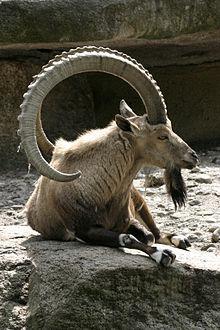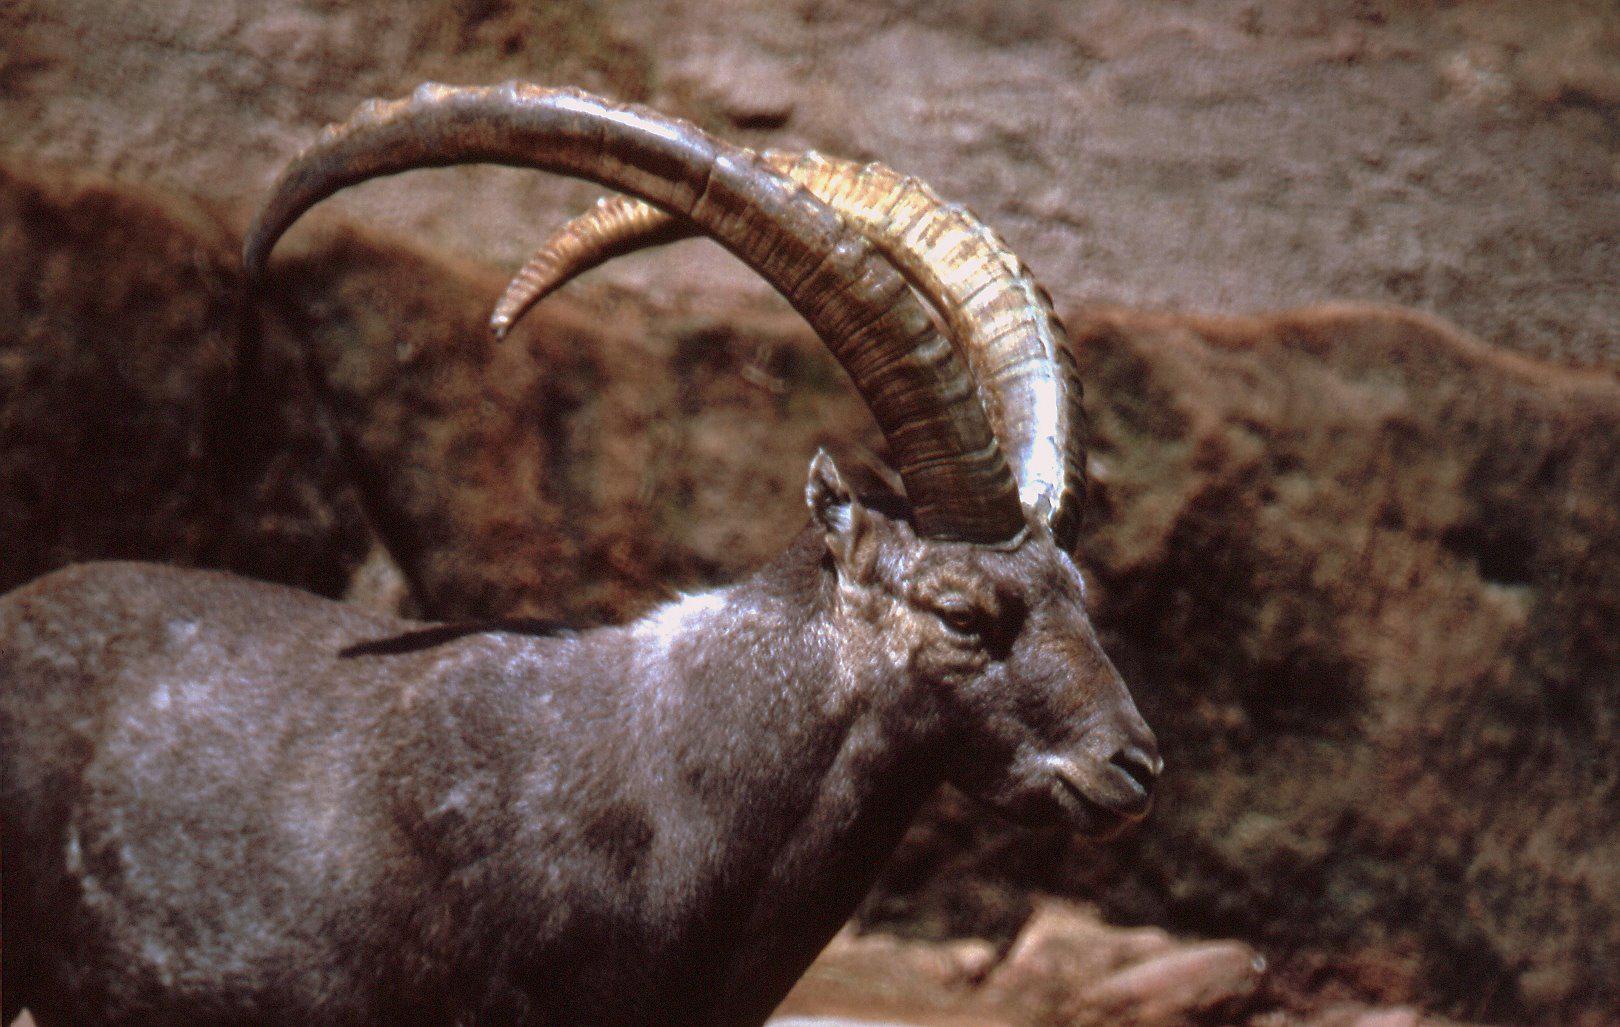The first image is the image on the left, the second image is the image on the right. Analyze the images presented: Is the assertion "One goat has its head down to the grass, while another goat is looking straight ahead." valid? Answer yes or no. No. The first image is the image on the left, the second image is the image on the right. Evaluate the accuracy of this statement regarding the images: "The horned animals in the right and left images face the same general direction, and at least one animal is reclining on the ground.". Is it true? Answer yes or no. Yes. 